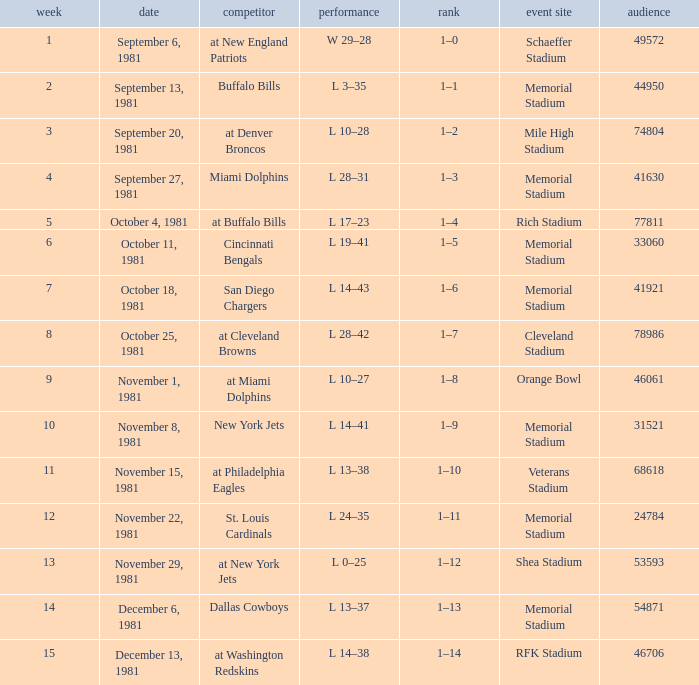When 74804 is the attendance what week is it? 3.0. 